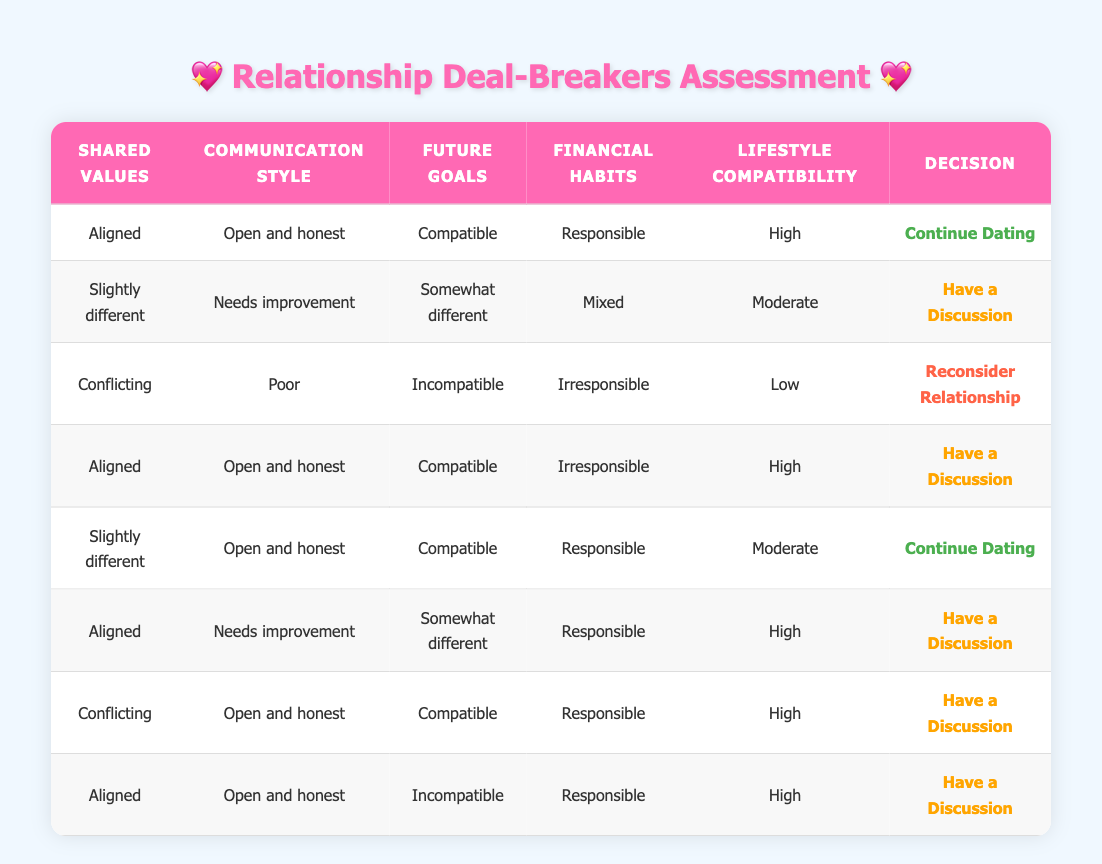What is the decision if the Shared Values are Conflicting and the Communication Style is Poor? According to the table, if the Shared Values are Conflicting and the Communication Style is Poor, the decision is to Reconsider Relationship as indicated in the corresponding row.
Answer: Reconsider Relationship How many decisions are labeled as "Continue Dating" in the table? There are two instances in the table where the decision is to Continue Dating: 1. Shared Values Aligned, Communication Style Open and honest, Future Goals Compatible, Financial Habits Responsible, Lifestyle Compatibility High. 2. Shared Values Slightly different, Communication Style Open and honest, Future Goals Compatible, Financial Habits Responsible, Lifestyle Compatibility Moderate.
Answer: 2 Are there any cases where the Shared Values are Aligned but the decision is to Reconsider Relationship? No, there are no instances where the Shared Values are Aligned and the decision is to Reconsider Relationship according to the data present in the table.
Answer: No What is the decision if the Financial Habits are Irresponsible and the Lifestyle Compatibility is High? There are two instances of this scenario in the table. One suggests having a discussion, while the other suggests to reconsider the relationship, indicating that context, such as Shared Values and Communication Style, will affect the final decision. Therefore, in these cases with Irresponsible Financial Habits and High Lifestyle Compatibility, the decision would depend on those other factors.
Answer: Depends on other factors What is the total number of decisions that recommend having a discussion? By counting the rows, there are five instances where the decision is to Have a Discussion: 1. Shared Values Slightly different, Communication Style Needs improvement, Future Goals Somewhat different, Financial Habits Mixed, Lifestyle Compatibility Moderate. 2. Shared Values Aligned, Communication Style Open and honest, Future Goals Compatible, Financial Habits Irresponsible, Lifestyle Compatibility High. 3. Shared Values Aligned, Communication Style Needs improvement, Future Goals Somewhat different, Financial Habits Responsible, Lifestyle Compatibility High. 4. Shared Values Conflicting, Communication Style Open and honest, Future Goals Compatible, Financial Habits Responsible, Lifestyle Compatibility High. 5. Shared Values Aligned, Communication Style Open and honest, Future Goals Incompatible, Financial Habits Responsible, Lifestyle Compatibility High.
Answer: 5 Are there scenarios where the Communication Style is Open and Honest but the decision is to Reconsider? No, all instances where the Communication Style is Open and Honest lead to either Continue Dating or Have a Discussion, but not Reconsider Relationship.
Answer: No 